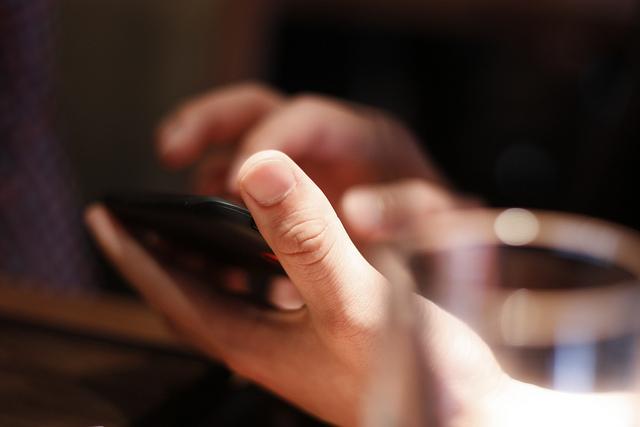What is in the persons left hand?
Write a very short answer. Phone. What is in the person's hand?
Be succinct. Phone. Is this woman's nails short?
Give a very brief answer. Yes. Are the fingernails of the hand painted brightly?
Give a very brief answer. No. What type of phone is this?
Quick response, please. Cell. Is the hand in focus?
Short answer required. Yes. Is this a man's hand or a woman's hand?
Answer briefly. Man. Man or woman's hands?
Short answer required. Woman. 